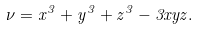<formula> <loc_0><loc_0><loc_500><loc_500>\nu = x ^ { 3 } + y ^ { 3 } + z ^ { 3 } - 3 x y z .</formula> 